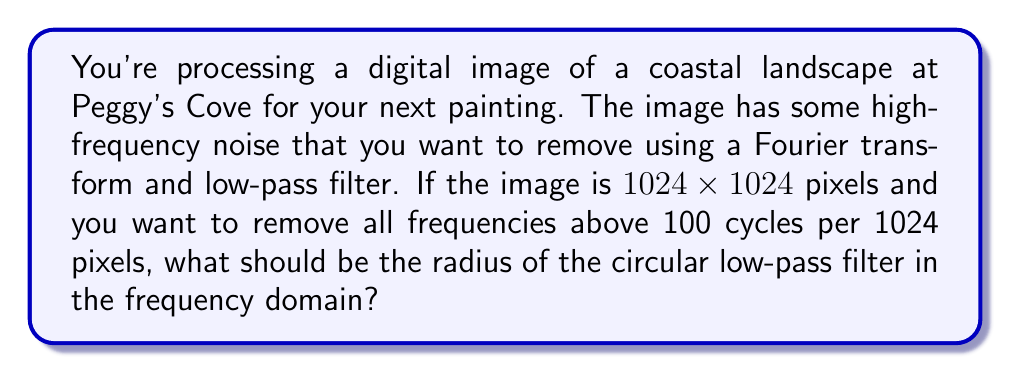Solve this math problem. To solve this problem, we need to understand how the Fourier transform represents an image in the frequency domain and how to apply a low-pass filter.

1. In the frequency domain, the image is represented as a 1024x1024 grid of frequency components.

2. The center of this grid (at coordinates (512, 512)) represents the DC component (zero frequency).

3. The maximum frequency in each dimension is at the edges, representing 512 cycles per 1024 pixels (Nyquist frequency).

4. We want to remove all frequencies above 100 cycles per 1024 pixels.

5. To calculate the radius of our circular low-pass filter, we need to determine how many pixels correspond to 100 cycles in the frequency domain:

   $$\text{radius} = \frac{100 \text{ cycles}}{512 \text{ cycles}} \times 512 \text{ pixels}$$

6. Simplifying:

   $$\text{radius} = 100 \text{ pixels}$$

7. Therefore, our low-pass filter should be a circle with a radius of 100 pixels centered at (512, 512) in the frequency domain.

8. All frequency components outside this circle will be set to zero, effectively removing high-frequency noise from the image.
Answer: The radius of the circular low-pass filter in the frequency domain should be 100 pixels. 